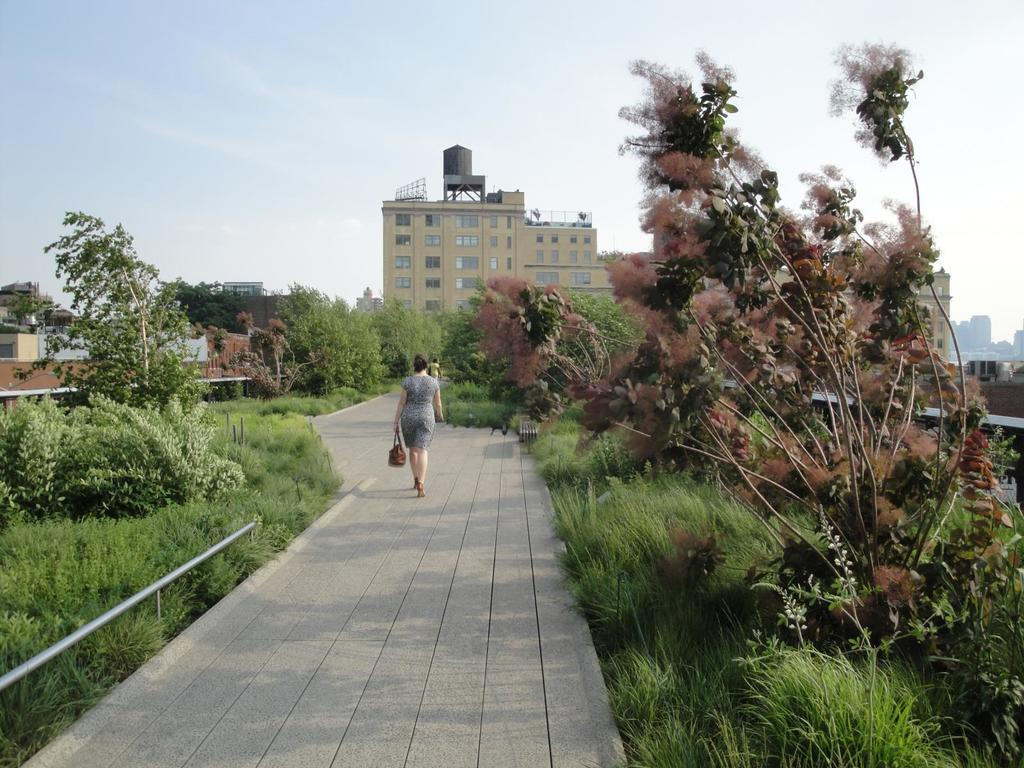What are the people in the image doing? The people in the image are walking on the pavement. What type of vegetation can be seen on both sides of the image? There are trees on both sides of the image. What type of ground surface is visible in the image? There is grass visible in the image. What can be seen in the background of the image? There is a building and the sky visible in the background of the image. What type of animal is being used to light a match in the image? There is no animal or match present in the image. What is the people in the image writing on the grass? There is no writing or activity involving writing in the image. 